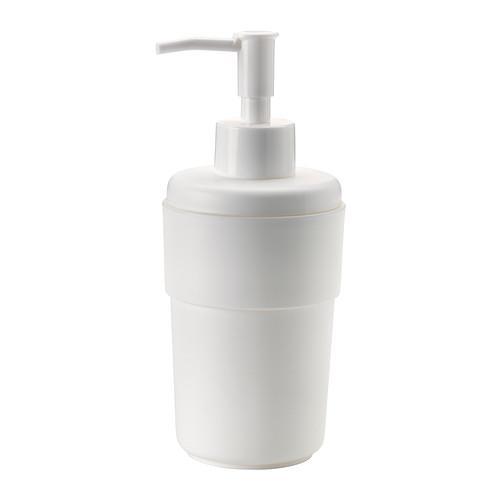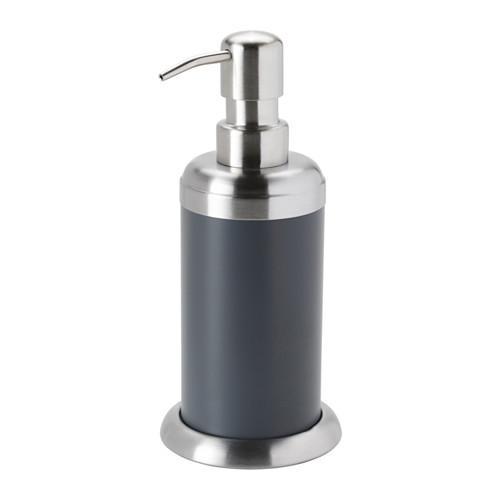The first image is the image on the left, the second image is the image on the right. Examine the images to the left and right. Is the description "Someone is using the dispenser in one of the images." accurate? Answer yes or no. No. 